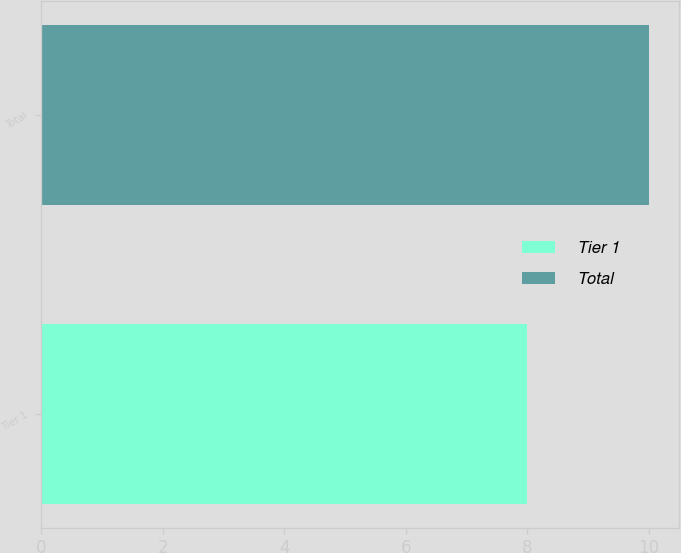Convert chart. <chart><loc_0><loc_0><loc_500><loc_500><bar_chart><fcel>Tier 1<fcel>Total<nl><fcel>8<fcel>10<nl></chart> 